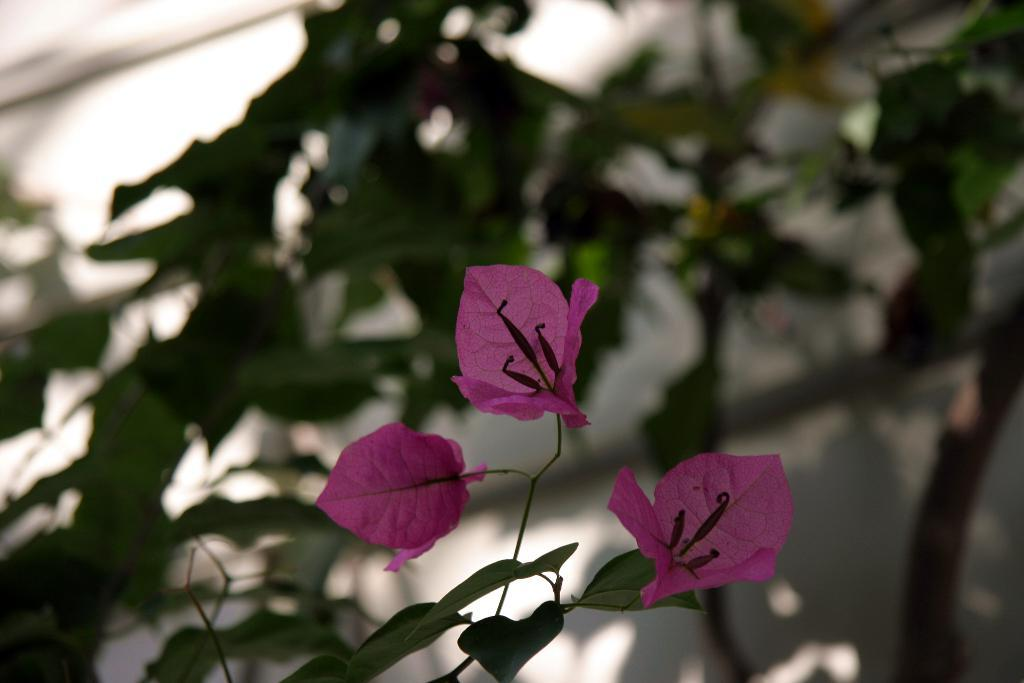What type of plant material can be seen in the image? There are leaves and buds in the image. How would you describe the overall focus of the image? The background of the image is blurred. How long does it take for the person to finish reading the book in the image? There is no person or book present in the image, so it is not possible to determine how long it would take to read a book. 